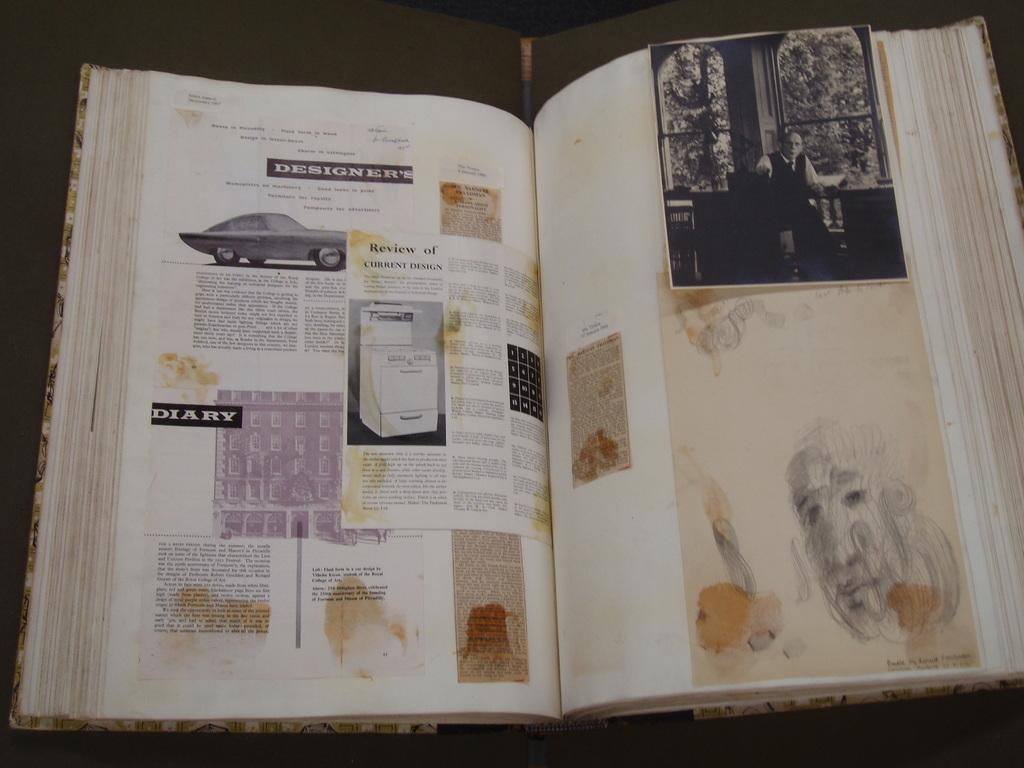<image>
Share a concise interpretation of the image provided. A book is open to a page with the word diary on it. 